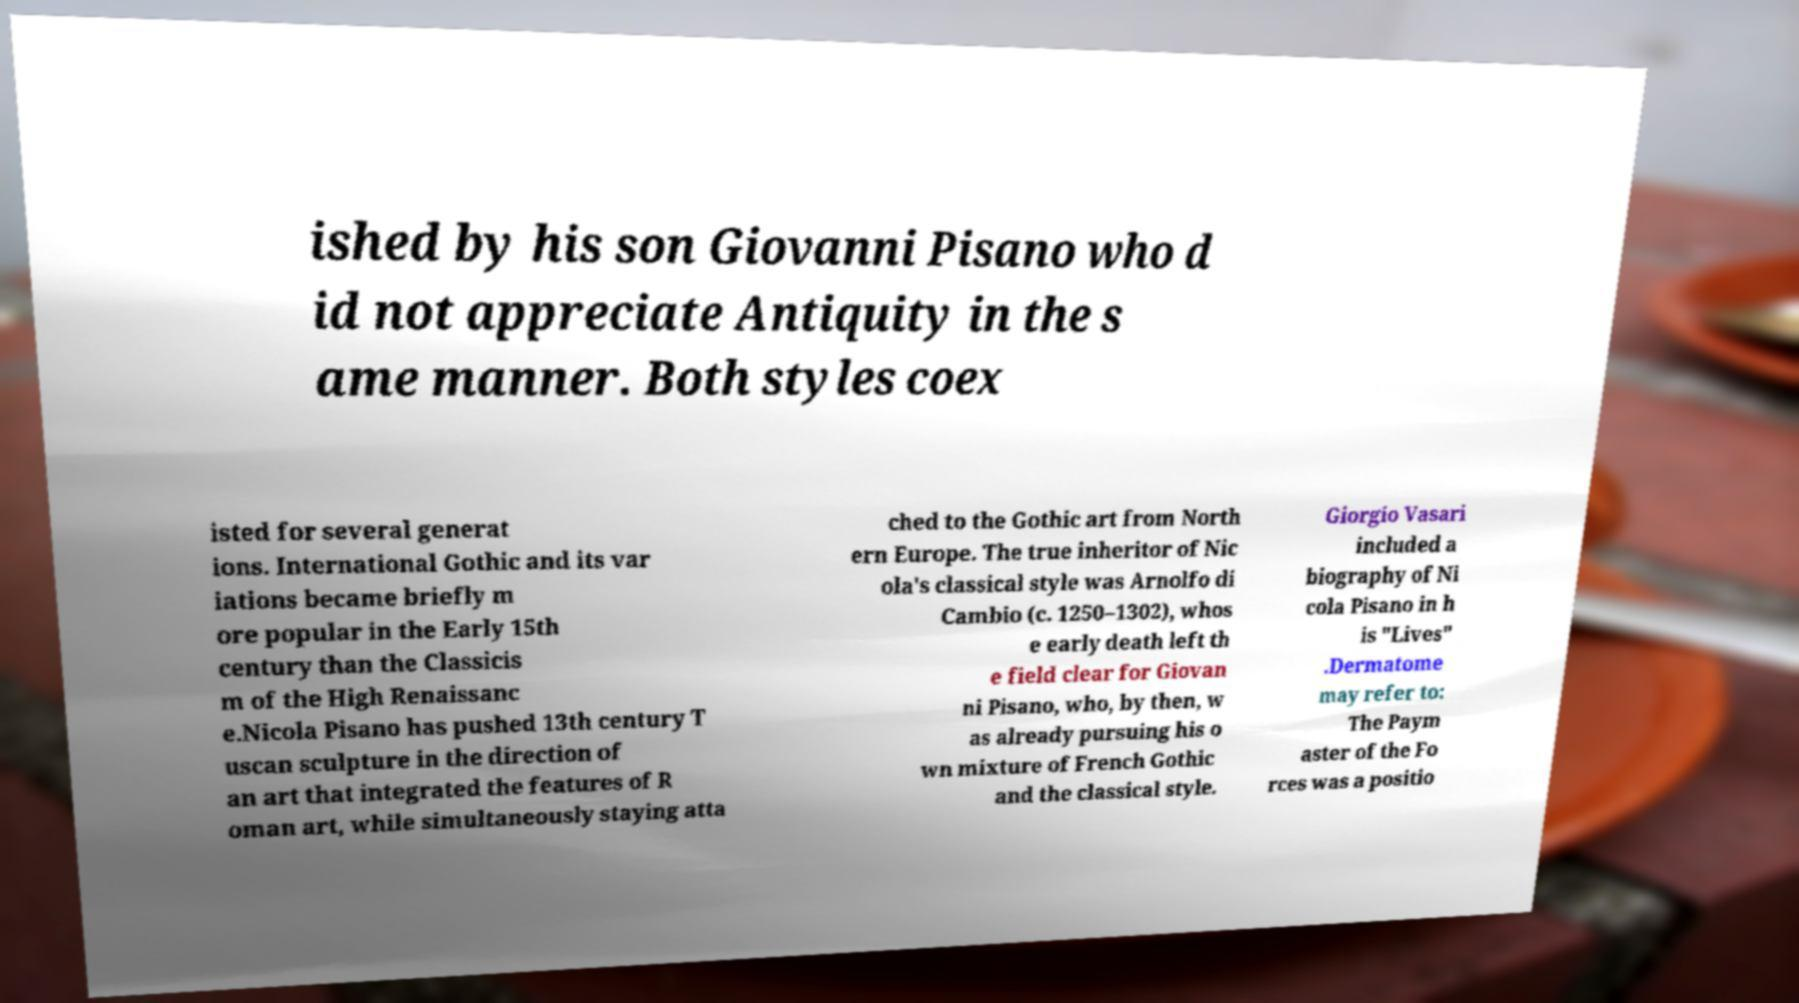Can you read and provide the text displayed in the image?This photo seems to have some interesting text. Can you extract and type it out for me? ished by his son Giovanni Pisano who d id not appreciate Antiquity in the s ame manner. Both styles coex isted for several generat ions. International Gothic and its var iations became briefly m ore popular in the Early 15th century than the Classicis m of the High Renaissanc e.Nicola Pisano has pushed 13th century T uscan sculpture in the direction of an art that integrated the features of R oman art, while simultaneously staying atta ched to the Gothic art from North ern Europe. The true inheritor of Nic ola's classical style was Arnolfo di Cambio (c. 1250–1302), whos e early death left th e field clear for Giovan ni Pisano, who, by then, w as already pursuing his o wn mixture of French Gothic and the classical style. Giorgio Vasari included a biography of Ni cola Pisano in h is "Lives" .Dermatome may refer to: The Paym aster of the Fo rces was a positio 